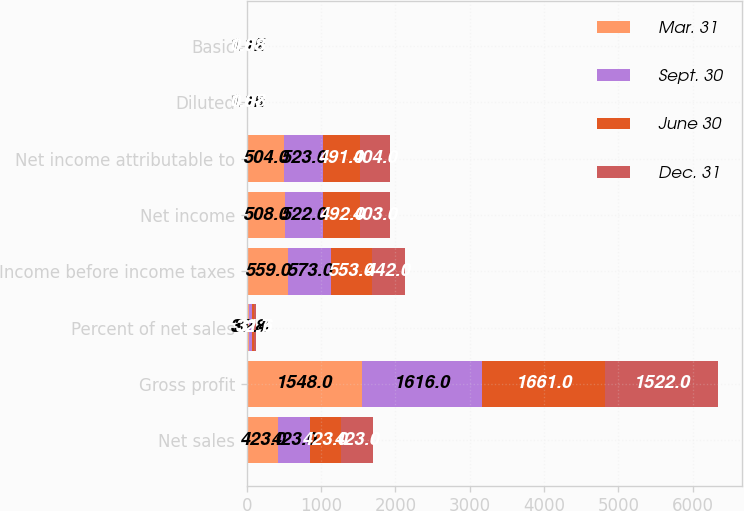Convert chart to OTSL. <chart><loc_0><loc_0><loc_500><loc_500><stacked_bar_chart><ecel><fcel>Net sales<fcel>Gross profit<fcel>Percent of net sales<fcel>Income before income taxes<fcel>Net income<fcel>Net income attributable to<fcel>Diluted<fcel>Basic<nl><fcel>Mar. 31<fcel>423<fcel>1548<fcel>31.8<fcel>559<fcel>508<fcel>504<fcel>1.12<fcel>1.12<nl><fcel>Sept. 30<fcel>423<fcel>1616<fcel>32.4<fcel>573<fcel>522<fcel>523<fcel>1.15<fcel>1.15<nl><fcel>June 30<fcel>423<fcel>1661<fcel>32.7<fcel>553<fcel>492<fcel>491<fcel>1.07<fcel>1.08<nl><fcel>Dec. 31<fcel>423<fcel>1522<fcel>31.6<fcel>442<fcel>403<fcel>404<fcel>0.88<fcel>0.88<nl></chart> 